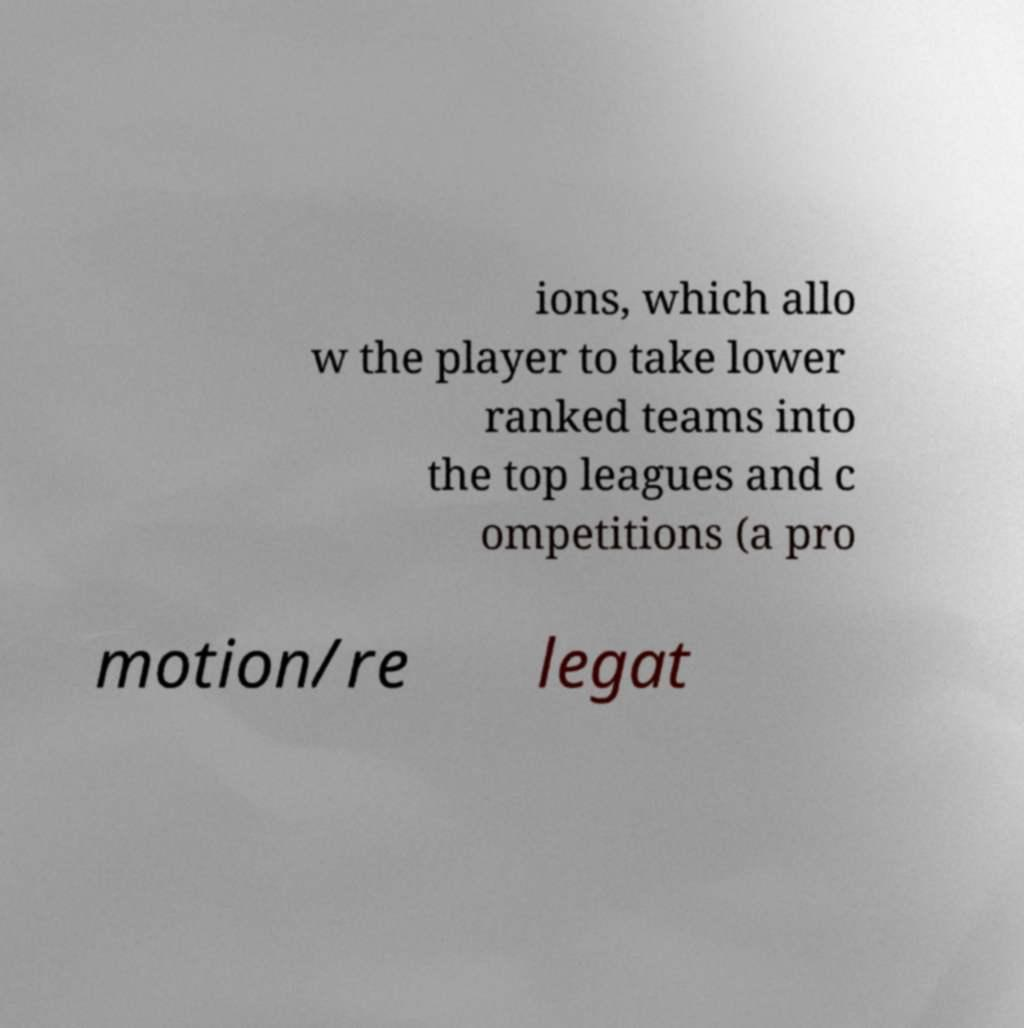For documentation purposes, I need the text within this image transcribed. Could you provide that? ions, which allo w the player to take lower ranked teams into the top leagues and c ompetitions (a pro motion/re legat 